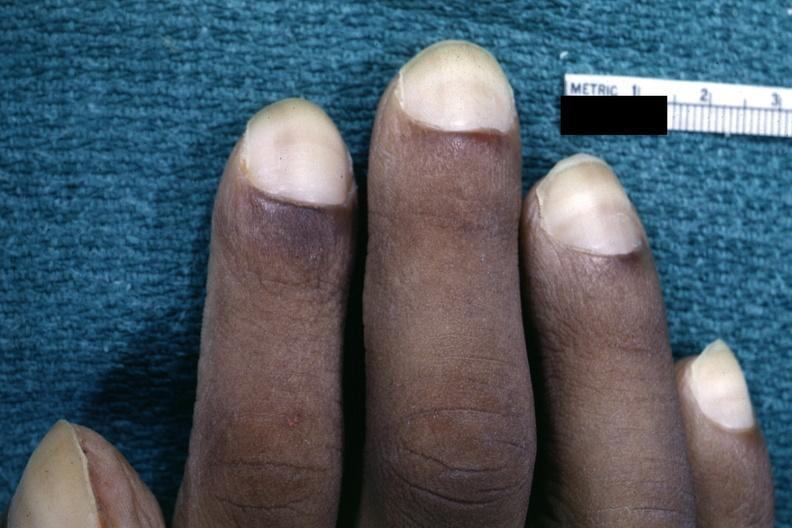re skin over back a buttocks present?
Answer the question using a single word or phrase. No 